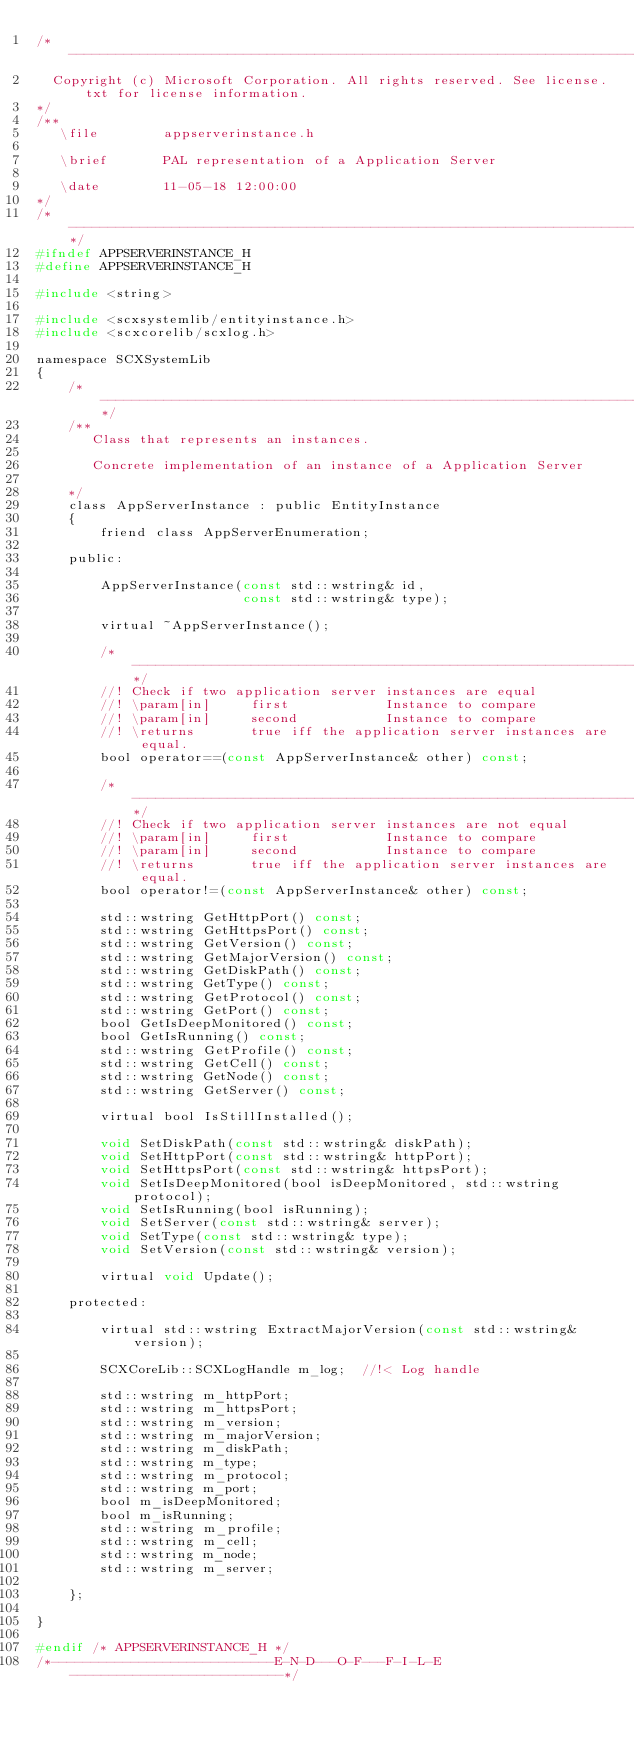Convert code to text. <code><loc_0><loc_0><loc_500><loc_500><_C_>/*--------------------------------------------------------------------------------
  Copyright (c) Microsoft Corporation. All rights reserved. See license.txt for license information.
*/
/**
   \file        appserverinstance.h

   \brief       PAL representation of a Application Server

   \date        11-05-18 12:00:00
*/
/*----------------------------------------------------------------------------*/
#ifndef APPSERVERINSTANCE_H
#define APPSERVERINSTANCE_H

#include <string>

#include <scxsystemlib/entityinstance.h>
#include <scxcorelib/scxlog.h>

namespace SCXSystemLib
{
    /*----------------------------------------------------------------------------*/
    /**
       Class that represents an instances.

       Concrete implementation of an instance of a Application Server

    */
    class AppServerInstance : public EntityInstance
    {
        friend class AppServerEnumeration;

    public:

        AppServerInstance(const std::wstring& id,
                          const std::wstring& type);

        virtual ~AppServerInstance();
        
        /*-------------------------------------------------------------------*/
        //! Check if two application server instances are equal
        //! \param[in]     first            Instance to compare
        //! \param[in]     second           Instance to compare
        //! \returns       true iff the application server instances are equal.
        bool operator==(const AppServerInstance& other) const;

        /*--------------------------------------------------------------------*/
        //! Check if two application server instances are not equal
        //! \param[in]     first            Instance to compare
        //! \param[in]     second           Instance to compare
        //! \returns       true iff the application server instances are equal.
        bool operator!=(const AppServerInstance& other) const;

        std::wstring GetHttpPort() const;
        std::wstring GetHttpsPort() const;
        std::wstring GetVersion() const;
        std::wstring GetMajorVersion() const;
        std::wstring GetDiskPath() const;
        std::wstring GetType() const;
        std::wstring GetProtocol() const;
        std::wstring GetPort() const;
        bool GetIsDeepMonitored() const;
        bool GetIsRunning() const;
        std::wstring GetProfile() const;
        std::wstring GetCell() const;
        std::wstring GetNode() const;
        std::wstring GetServer() const;

        virtual bool IsStillInstalled();

        void SetDiskPath(const std::wstring& diskPath);
        void SetHttpPort(const std::wstring& httpPort);
        void SetHttpsPort(const std::wstring& httpsPort);
        void SetIsDeepMonitored(bool isDeepMonitored, std::wstring protocol);
        void SetIsRunning(bool isRunning);
        void SetServer(const std::wstring& server);
        void SetType(const std::wstring& type);
        void SetVersion(const std::wstring& version);

        virtual void Update();

    protected:

        virtual std::wstring ExtractMajorVersion(const std::wstring& version);

        SCXCoreLib::SCXLogHandle m_log;  //!< Log handle

        std::wstring m_httpPort;
        std::wstring m_httpsPort;
        std::wstring m_version;
        std::wstring m_majorVersion;
        std::wstring m_diskPath;
        std::wstring m_type;
        std::wstring m_protocol;
        std::wstring m_port;
        bool m_isDeepMonitored;
        bool m_isRunning;
        std::wstring m_profile;
        std::wstring m_cell;
        std::wstring m_node;
        std::wstring m_server;

    };

}

#endif /* APPSERVERINSTANCE_H */
/*----------------------------E-N-D---O-F---F-I-L-E---------------------------*/
</code> 